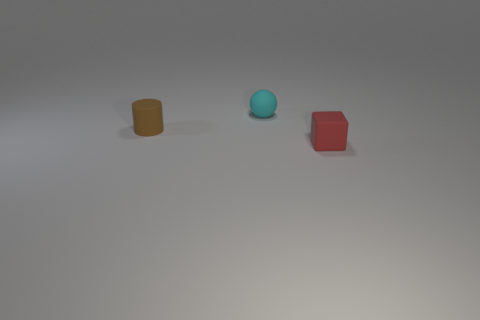There is a matte object right of the tiny matte object behind the small thing to the left of the small rubber sphere; what is its size?
Provide a short and direct response. Small. There is a sphere that is the same size as the matte cylinder; what is its material?
Your answer should be compact. Rubber. Are there any red matte things of the same size as the red cube?
Provide a short and direct response. No. Does the thing on the left side of the cyan sphere have the same size as the red object?
Provide a succinct answer. Yes. There is a small object that is both in front of the tiny sphere and to the right of the tiny rubber cylinder; what shape is it?
Offer a very short reply. Cube. Is the number of rubber cylinders behind the ball greater than the number of large cyan matte balls?
Provide a short and direct response. No. What size is the cylinder that is made of the same material as the tiny cyan thing?
Offer a terse response. Small. Is the color of the small rubber thing to the left of the cyan matte sphere the same as the rubber sphere?
Make the answer very short. No. Are there an equal number of tiny brown rubber cylinders behind the matte sphere and tiny cylinders that are left of the red cube?
Give a very brief answer. No. Are there any other things that are made of the same material as the cylinder?
Your response must be concise. Yes. 